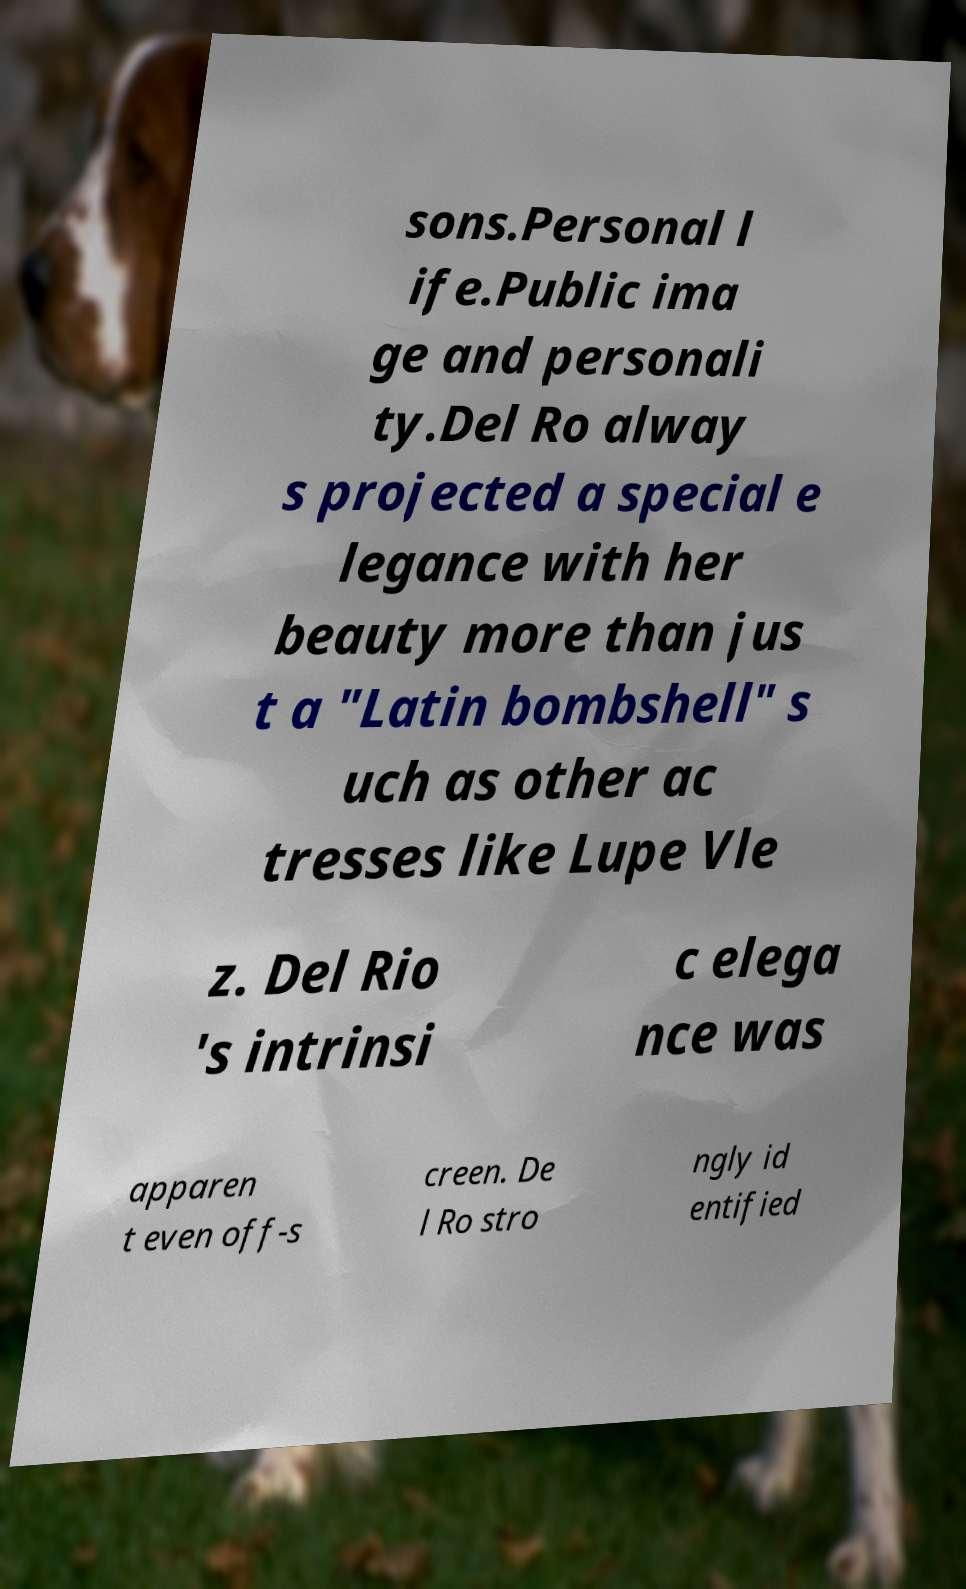For documentation purposes, I need the text within this image transcribed. Could you provide that? sons.Personal l ife.Public ima ge and personali ty.Del Ro alway s projected a special e legance with her beauty more than jus t a "Latin bombshell" s uch as other ac tresses like Lupe Vle z. Del Rio 's intrinsi c elega nce was apparen t even off-s creen. De l Ro stro ngly id entified 